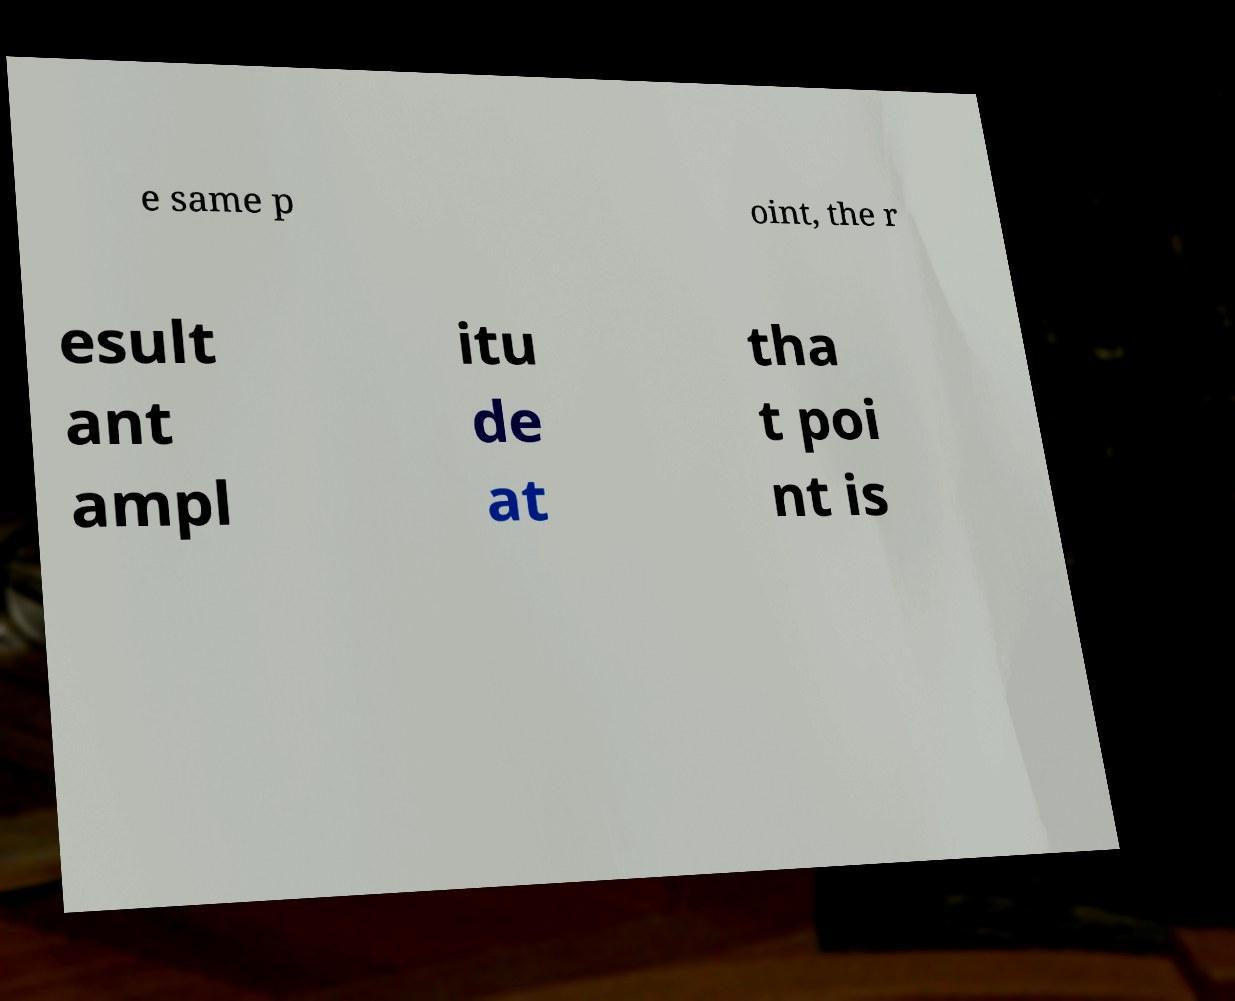Could you extract and type out the text from this image? e same p oint, the r esult ant ampl itu de at tha t poi nt is 